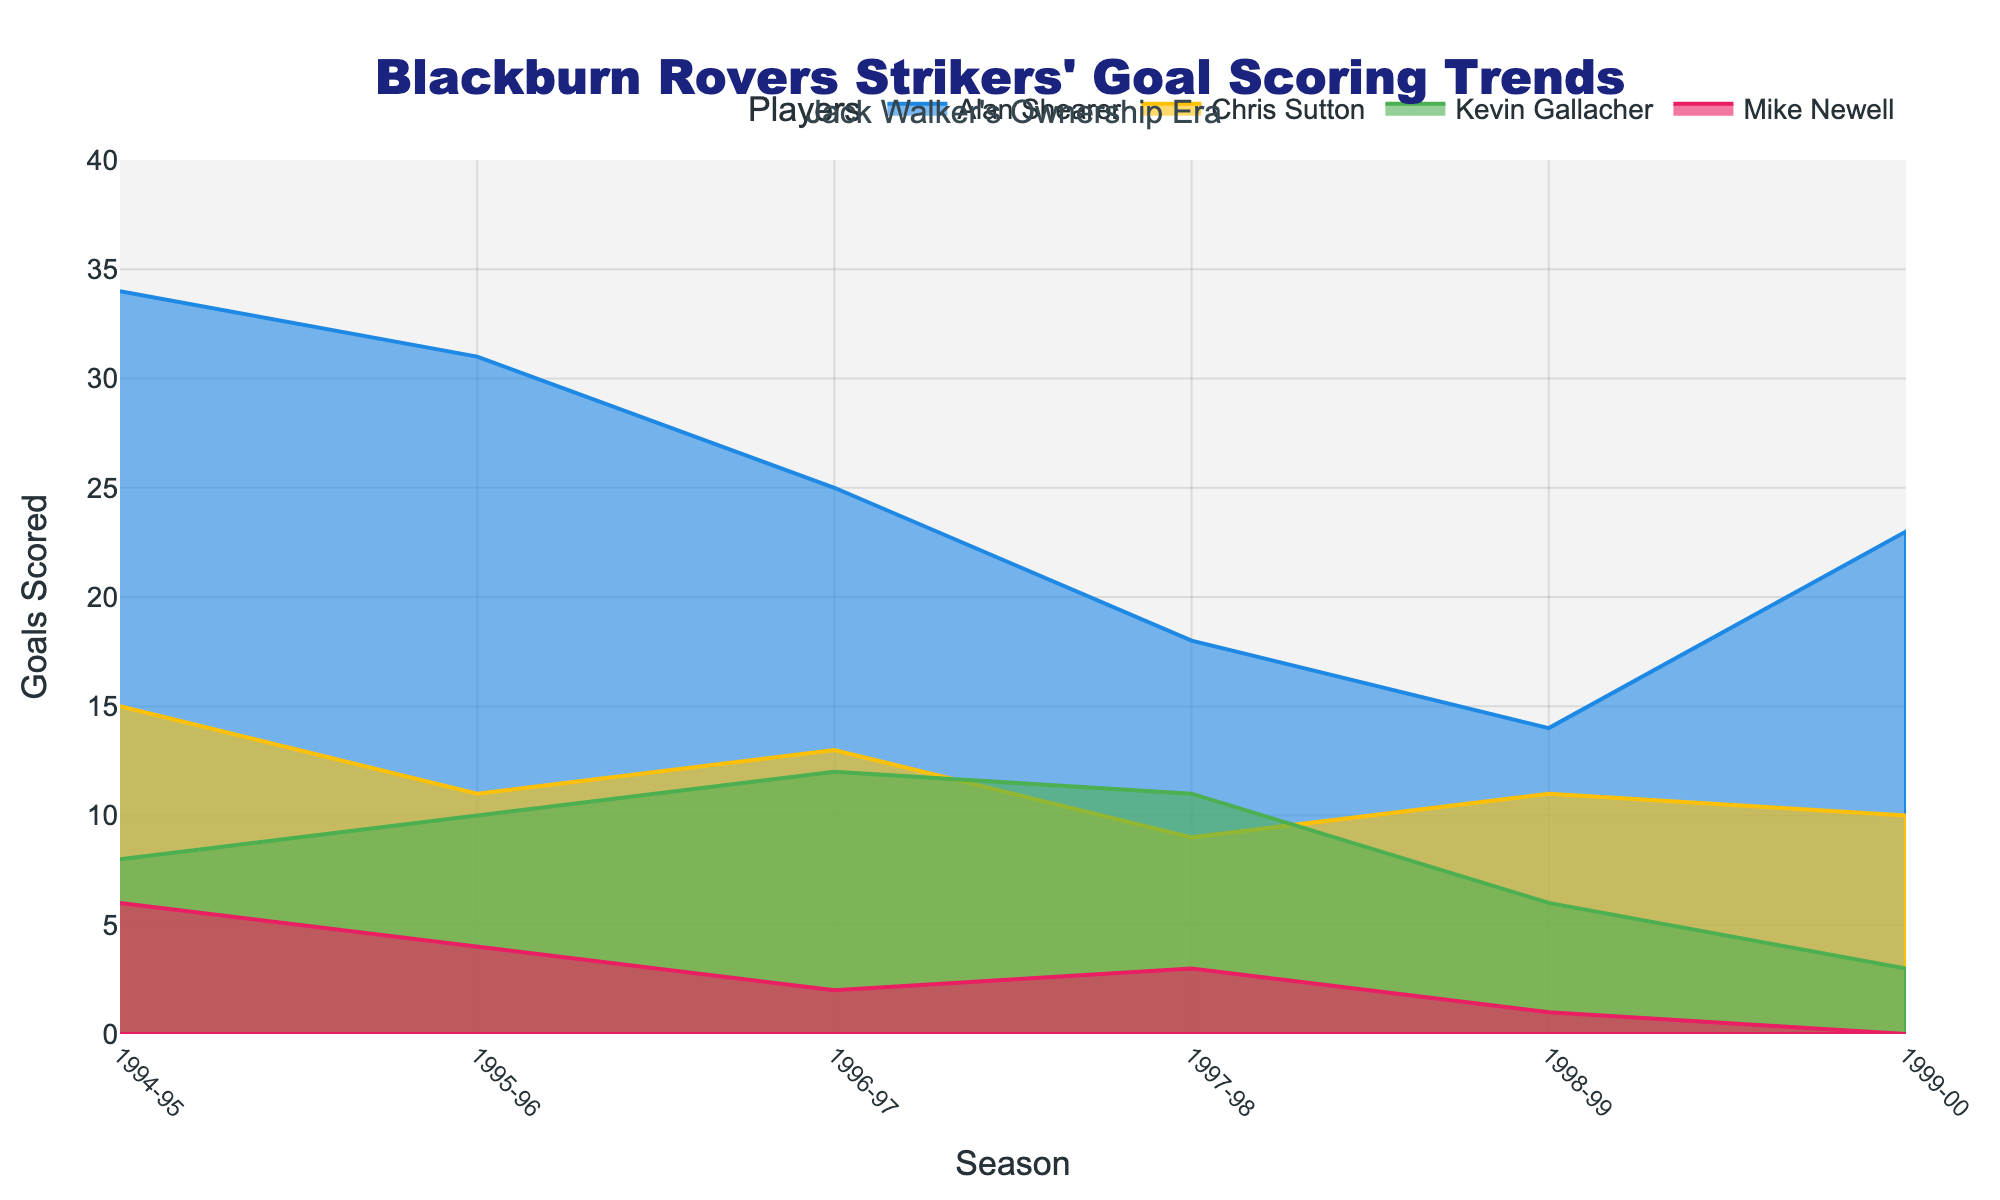What's the highest number of goals scored by Alan Shearer in a single season? Alan Shearer's peak goal-scoring season, indicated by the uppermost point of the blue area, was in the 1994-95 season with 34 goals.
Answer: 34 How many seasons did Chris Sutton score more than 10 goals? By examining the yellow area representing Chris Sutton, we see that he scored more than 10 goals in 4 seasons (1994-95, 1995-96, 1996-97, 1998-99).
Answer: 4 During which season did Kevin Gallacher score the most goals? Looking at the green area for Kevin Gallacher, his highest point is in the 1996-97 season, where he scored 12 goals.
Answer: 1996-97 Which striker scored the fewest goals in the 1999-00 season? Observing the 1999-00 season, Mike Newell’s magenta area is at zero, indicating he scored no goals, which is the fewest among all strikers that season.
Answer: Mike Newell In which season does the chart show the combined lowest goal total for all strikers? To find the combined lowest total, sum up the goal values for each season and compare them: 1999-00 season (23+10+3+0=36) is the lowest total scored by all strikers.
Answer: 1999-00 Which two players combined had the same goal total in the 1997-98 season? Reviewing the values for the 1997-98 season, Alan Shearer (18) and Chris Sutton (9) combined equal the total scored by Kevin Gallacher (11) and Mike Newell (3), both sums adding up to 27.
Answer: Alan Shearer and Chris Sutton, Kevin Gallacher and Mike Newell What's the difference in goals scored by Alan Shearer in the 1994-95 and 1998-99 seasons? Subtract the goals scored by Alan Shearer in the 1998-99 season (14) from those in the 1994-95 season (34), resulting in a difference of 20 goals.
Answer: 20 Compare Chris Sutton's goal trend from 1994-95 to 1997-98. Did it increase or decrease overall? From 1994-95 to 1997-98, Chris Sutton’s goal count shows a decreasing trend: 15, 11, 13, 9.
Answer: Decrease Who consistently scored the fewest goals across all seasons? The magenta area representing Mike Newell consistently stays lower compared to areas for other strikers, indicating he scored the fewest goals consistently.
Answer: Mike Newell 